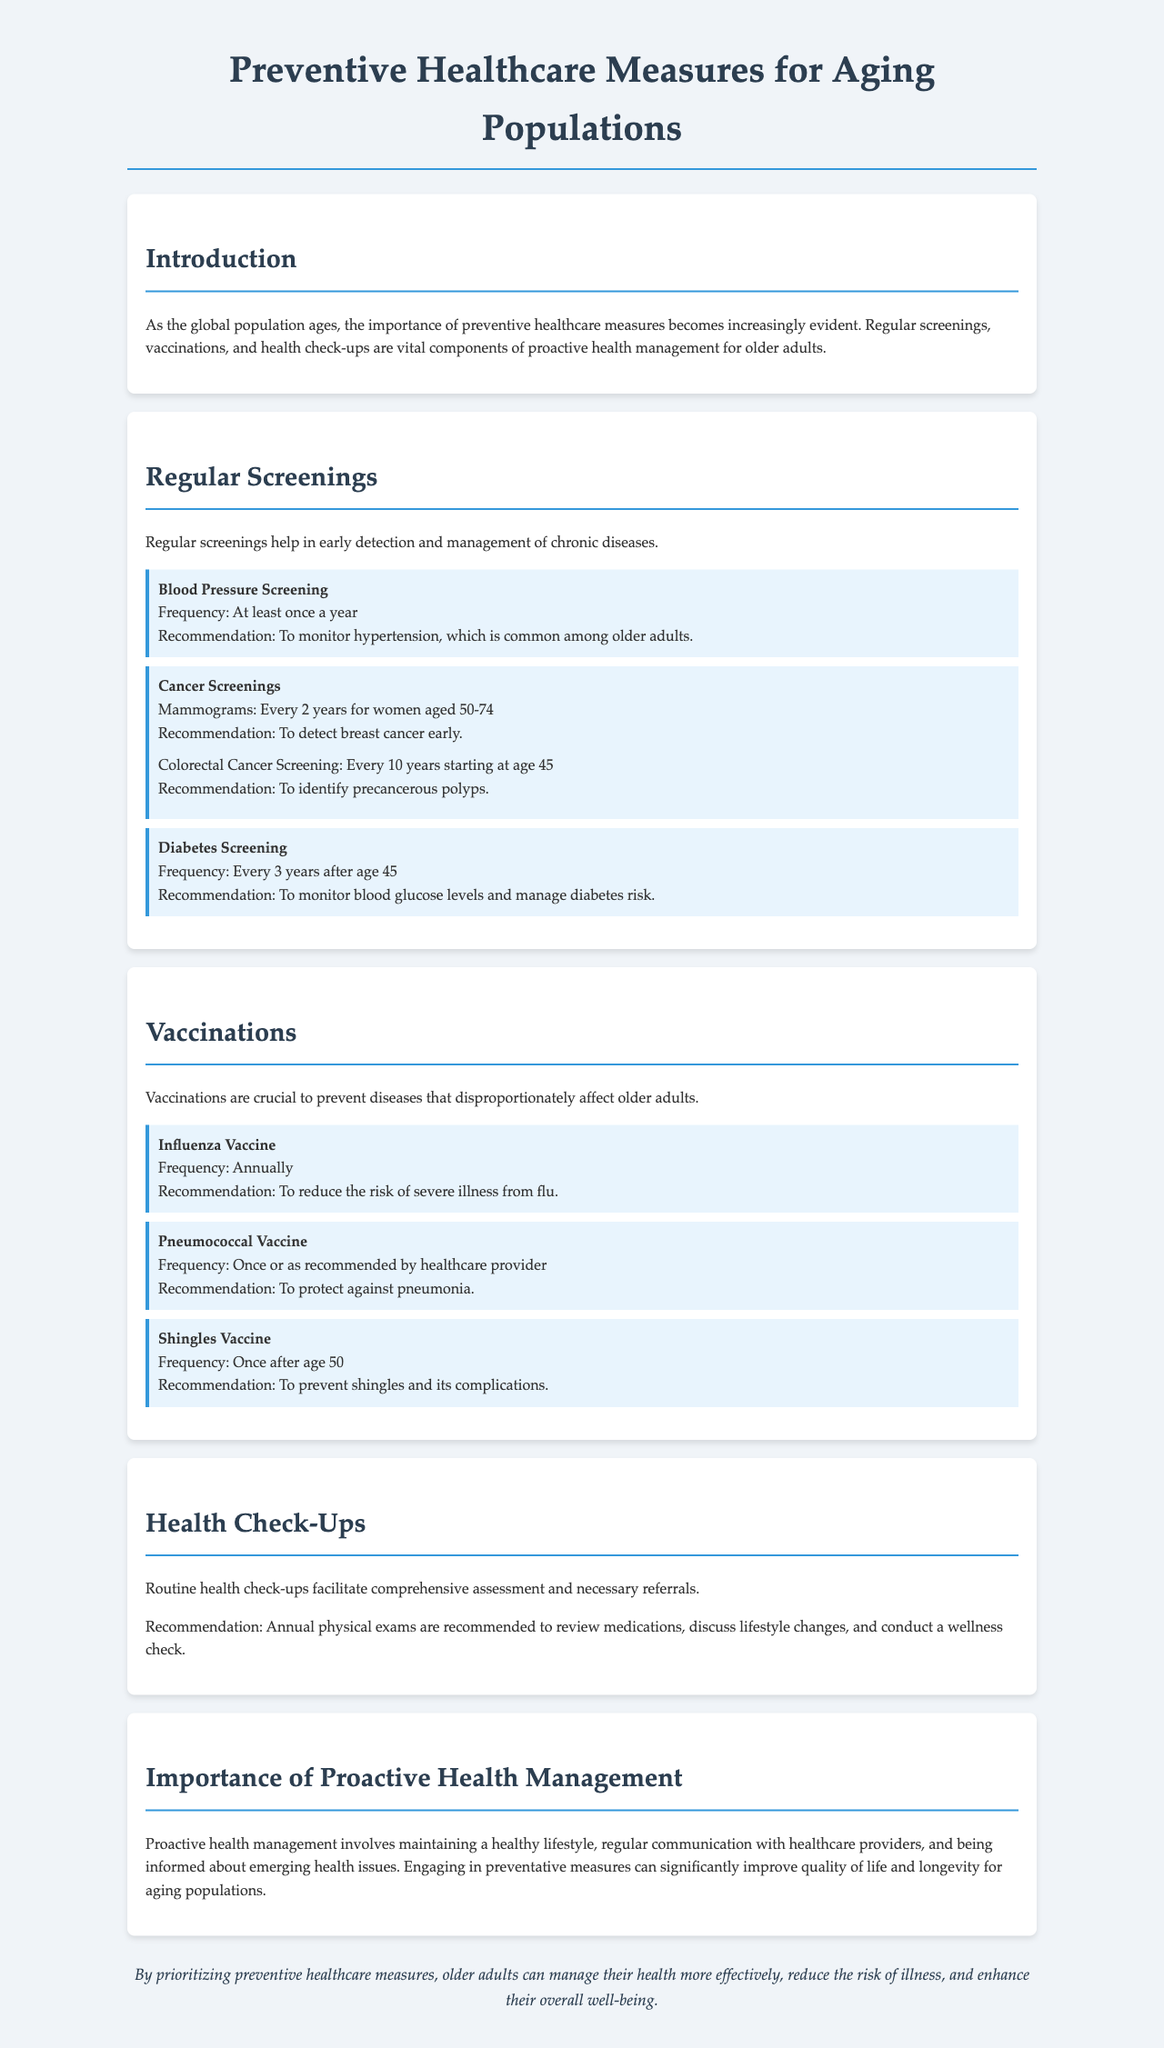What is the main focus of the document? The document primarily discusses preventive healthcare measures tailored for older adults, including screenings, vaccinations, and health check-ups.
Answer: Preventive healthcare measures for aging populations How often should older adults undergo blood pressure screening? The document specifies that blood pressure screening should occur at least once a year.
Answer: At least once a year What types of cancer screenings are mentioned? The document lists mammograms and colorectal cancer screenings as types of cancer screenings recommended for older adults.
Answer: Mammograms and colorectal cancer screenings At what age should diabetes screening begin? The document notes that diabetes screening should start at age 45.
Answer: Age 45 How frequently should the influenza vaccine be administered? It is stated in the document that the influenza vaccine should be given annually.
Answer: Annually What is the recommendation for annual health check-ups? The document recommends annual physical exams to review medications, discuss lifestyle changes, and conduct wellness checks.
Answer: Annual physical exams What is the significance of proactive health management for aging populations? The document explains that proactive health management significantly improves quality of life and longevity.
Answer: Improves quality of life and longevity What is the recommended frequency for the pneumonia vaccine? According to the document, the pneumonia vaccine should be administered once or as recommended by a healthcare provider.
Answer: Once or as recommended by healthcare provider 